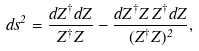<formula> <loc_0><loc_0><loc_500><loc_500>d s ^ { 2 } = \frac { d Z ^ { \dag } d Z } { Z ^ { \dag } Z } - \frac { d Z ^ { \dag } Z \, Z ^ { \dag } d Z } { ( Z ^ { \dag } Z ) ^ { 2 } } ,</formula> 